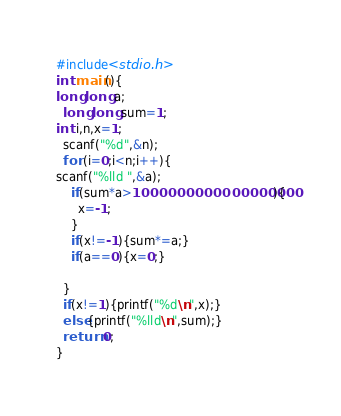Convert code to text. <code><loc_0><loc_0><loc_500><loc_500><_C_>#include<stdio.h>
int main(){
long long a;
  long long sum=1;
int i,n,x=1;
  scanf("%d",&n);
  for (i=0;i<n;i++){
scanf("%lld ",&a);
    if(sum*a>1000000000000000000){
      x=-1;
    }
    if(x!=-1){sum*=a;}
    if(a==0){x=0;}
    
  }
  if(x!=1){printf("%d\n",x);}
  else{printf("%lld\n",sum);}
  return 0;
}</code> 